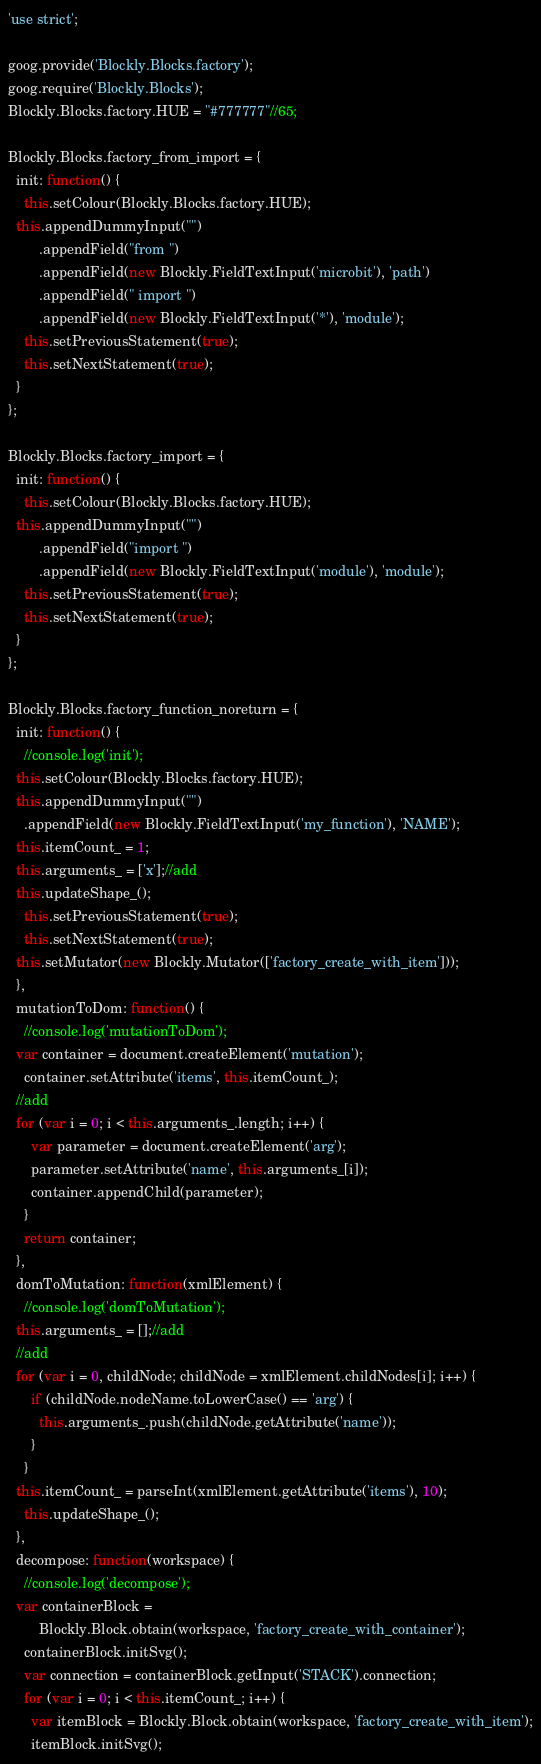<code> <loc_0><loc_0><loc_500><loc_500><_JavaScript_>'use strict';

goog.provide('Blockly.Blocks.factory');
goog.require('Blockly.Blocks');
Blockly.Blocks.factory.HUE = "#777777"//65;

Blockly.Blocks.factory_from_import = {
  init: function() {
    this.setColour(Blockly.Blocks.factory.HUE);
  this.appendDummyInput("")
        .appendField("from ")
        .appendField(new Blockly.FieldTextInput('microbit'), 'path')
        .appendField(" import ")
        .appendField(new Blockly.FieldTextInput('*'), 'module');
    this.setPreviousStatement(true);
    this.setNextStatement(true);
  }
};

Blockly.Blocks.factory_import = {
  init: function() {
    this.setColour(Blockly.Blocks.factory.HUE);
  this.appendDummyInput("")
        .appendField("import ")
        .appendField(new Blockly.FieldTextInput('module'), 'module');
    this.setPreviousStatement(true);
    this.setNextStatement(true);
  }
};

Blockly.Blocks.factory_function_noreturn = {
  init: function() {
    //console.log('init');
  this.setColour(Blockly.Blocks.factory.HUE);
  this.appendDummyInput("")
    .appendField(new Blockly.FieldTextInput('my_function'), 'NAME');
  this.itemCount_ = 1;
  this.arguments_ = ['x'];//add
  this.updateShape_();
    this.setPreviousStatement(true);
    this.setNextStatement(true);
  this.setMutator(new Blockly.Mutator(['factory_create_with_item']));
  },
  mutationToDom: function() {
    //console.log('mutationToDom');
  var container = document.createElement('mutation');
    container.setAttribute('items', this.itemCount_);
  //add
  for (var i = 0; i < this.arguments_.length; i++) {
      var parameter = document.createElement('arg');
      parameter.setAttribute('name', this.arguments_[i]);
      container.appendChild(parameter);
    }
    return container;
  },
  domToMutation: function(xmlElement) {
    //console.log('domToMutation');
  this.arguments_ = [];//add
  //add
  for (var i = 0, childNode; childNode = xmlElement.childNodes[i]; i++) {
      if (childNode.nodeName.toLowerCase() == 'arg') {
        this.arguments_.push(childNode.getAttribute('name'));
      }
    }
  this.itemCount_ = parseInt(xmlElement.getAttribute('items'), 10);
    this.updateShape_();
  },
  decompose: function(workspace) {
    //console.log('decompose');
  var containerBlock =
        Blockly.Block.obtain(workspace, 'factory_create_with_container');
    containerBlock.initSvg();
    var connection = containerBlock.getInput('STACK').connection;
    for (var i = 0; i < this.itemCount_; i++) {
      var itemBlock = Blockly.Block.obtain(workspace, 'factory_create_with_item');
      itemBlock.initSvg();</code> 